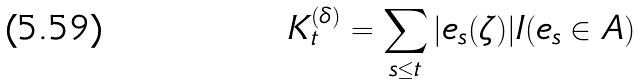Convert formula to latex. <formula><loc_0><loc_0><loc_500><loc_500>K _ { t } ^ { ( \delta ) } = \sum _ { s \leq t } | e _ { s } ( \zeta ) | I ( e _ { s } \in A )</formula> 